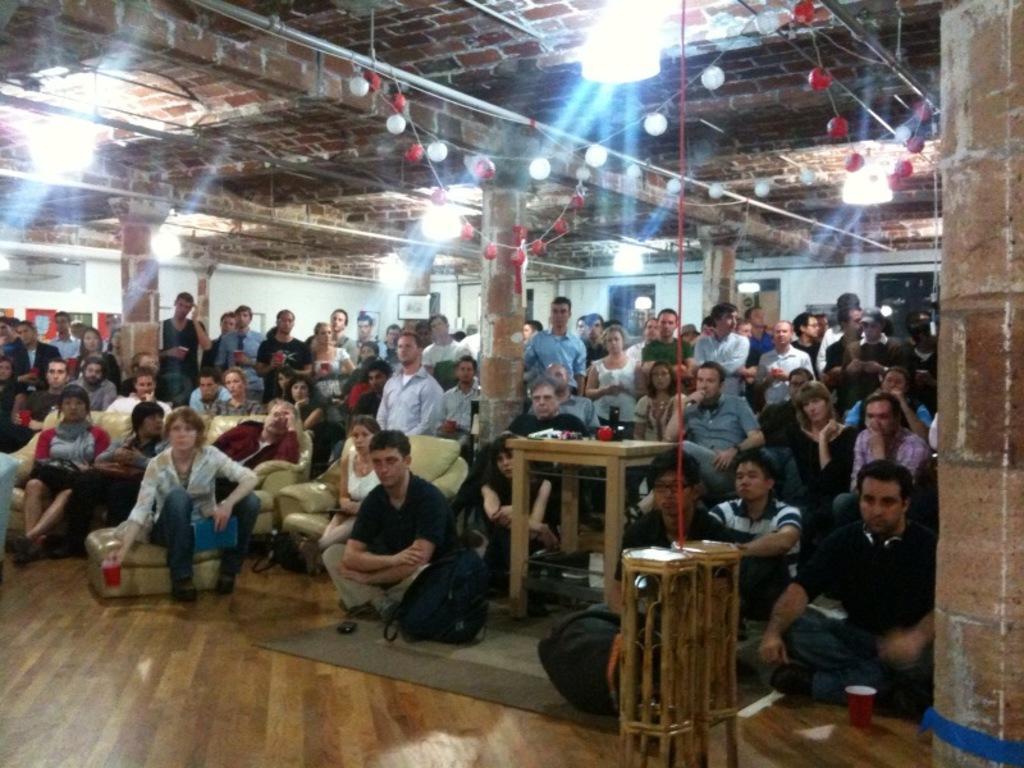Could you give a brief overview of what you see in this image? As we can see in the image there is a brick wall, few people standing and sitting here and there. In the front there are sofas and a suitcase and there is a table over here. 